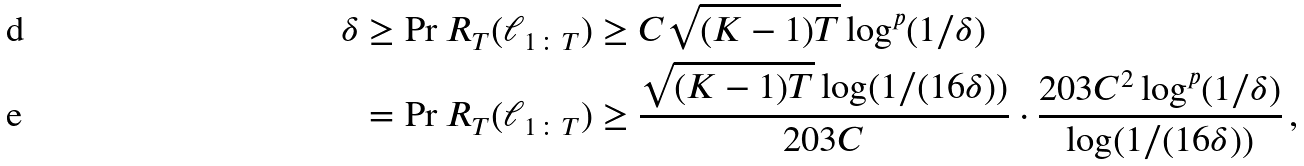<formula> <loc_0><loc_0><loc_500><loc_500>\delta & \geq \Pr { R _ { T } ( \ell _ { 1 \colon T } ) \geq C \sqrt { ( K - 1 ) T } \log ^ { p } ( 1 / \delta ) } \\ & = \Pr { R _ { T } ( \ell _ { 1 \colon T } ) \geq \frac { \sqrt { ( K - 1 ) T } \log ( 1 / ( 1 6 \delta ) ) } { 2 0 3 C } \cdot \frac { 2 0 3 C ^ { 2 } \log ^ { p } ( 1 / \delta ) } { \log ( 1 / ( 1 6 \delta ) ) } } \, ,</formula> 